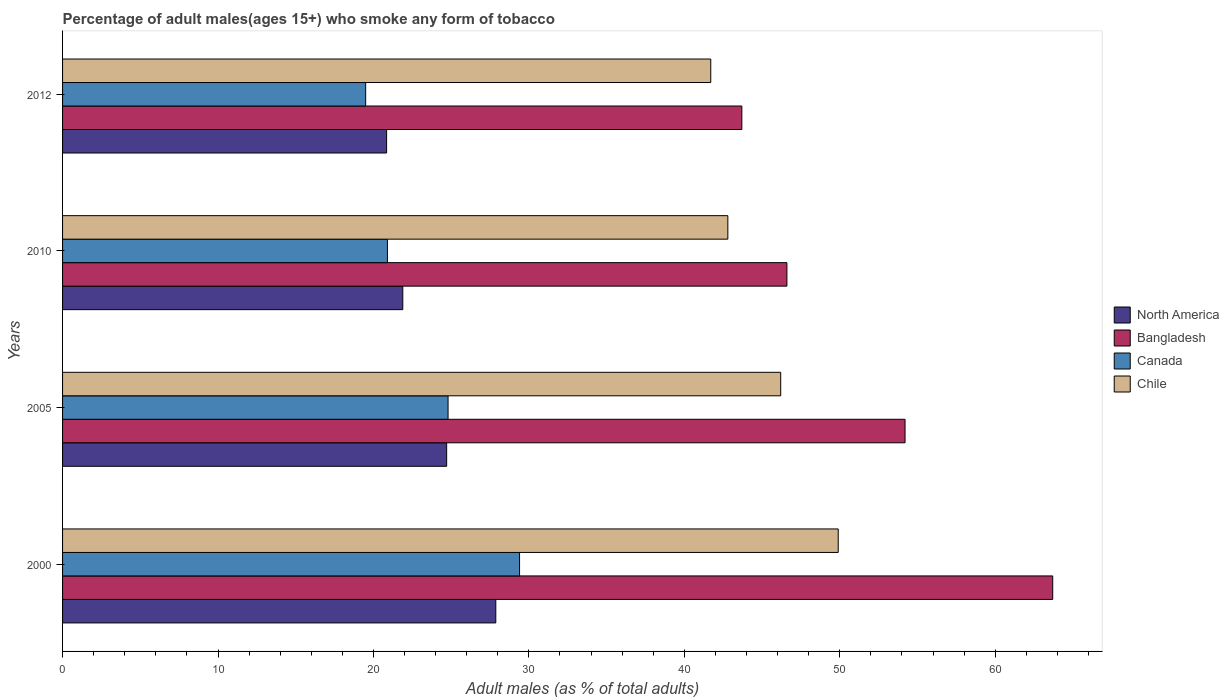How many bars are there on the 2nd tick from the top?
Your answer should be compact. 4. How many bars are there on the 2nd tick from the bottom?
Provide a short and direct response. 4. What is the label of the 4th group of bars from the top?
Offer a very short reply. 2000. In how many cases, is the number of bars for a given year not equal to the number of legend labels?
Provide a short and direct response. 0. What is the percentage of adult males who smoke in North America in 2005?
Your answer should be compact. 24.71. Across all years, what is the maximum percentage of adult males who smoke in Canada?
Keep it short and to the point. 29.4. Across all years, what is the minimum percentage of adult males who smoke in Canada?
Provide a succinct answer. 19.5. What is the total percentage of adult males who smoke in Canada in the graph?
Offer a terse response. 94.6. What is the difference between the percentage of adult males who smoke in Chile in 2000 and that in 2010?
Offer a very short reply. 7.1. What is the difference between the percentage of adult males who smoke in Bangladesh in 2010 and the percentage of adult males who smoke in Chile in 2000?
Provide a short and direct response. -3.3. What is the average percentage of adult males who smoke in Bangladesh per year?
Your response must be concise. 52.05. In the year 2005, what is the difference between the percentage of adult males who smoke in North America and percentage of adult males who smoke in Canada?
Give a very brief answer. -0.09. In how many years, is the percentage of adult males who smoke in North America greater than 26 %?
Give a very brief answer. 1. What is the ratio of the percentage of adult males who smoke in Canada in 2000 to that in 2005?
Keep it short and to the point. 1.19. Is the percentage of adult males who smoke in Bangladesh in 2000 less than that in 2012?
Provide a short and direct response. No. Is the difference between the percentage of adult males who smoke in North America in 2005 and 2012 greater than the difference between the percentage of adult males who smoke in Canada in 2005 and 2012?
Provide a short and direct response. No. What is the difference between the highest and the second highest percentage of adult males who smoke in Canada?
Your answer should be very brief. 4.6. What is the difference between the highest and the lowest percentage of adult males who smoke in North America?
Give a very brief answer. 7.02. In how many years, is the percentage of adult males who smoke in Chile greater than the average percentage of adult males who smoke in Chile taken over all years?
Your response must be concise. 2. Is the sum of the percentage of adult males who smoke in Canada in 2005 and 2012 greater than the maximum percentage of adult males who smoke in North America across all years?
Provide a succinct answer. Yes. Is it the case that in every year, the sum of the percentage of adult males who smoke in Chile and percentage of adult males who smoke in Bangladesh is greater than the sum of percentage of adult males who smoke in North America and percentage of adult males who smoke in Canada?
Provide a succinct answer. Yes. What does the 3rd bar from the top in 2000 represents?
Offer a terse response. Bangladesh. Is it the case that in every year, the sum of the percentage of adult males who smoke in North America and percentage of adult males who smoke in Chile is greater than the percentage of adult males who smoke in Bangladesh?
Make the answer very short. Yes. How many bars are there?
Give a very brief answer. 16. What is the difference between two consecutive major ticks on the X-axis?
Give a very brief answer. 10. Does the graph contain grids?
Make the answer very short. No. Where does the legend appear in the graph?
Offer a terse response. Center right. How are the legend labels stacked?
Offer a terse response. Vertical. What is the title of the graph?
Offer a terse response. Percentage of adult males(ages 15+) who smoke any form of tobacco. What is the label or title of the X-axis?
Provide a succinct answer. Adult males (as % of total adults). What is the label or title of the Y-axis?
Your response must be concise. Years. What is the Adult males (as % of total adults) of North America in 2000?
Your answer should be compact. 27.87. What is the Adult males (as % of total adults) in Bangladesh in 2000?
Offer a terse response. 63.7. What is the Adult males (as % of total adults) in Canada in 2000?
Make the answer very short. 29.4. What is the Adult males (as % of total adults) of Chile in 2000?
Offer a terse response. 49.9. What is the Adult males (as % of total adults) of North America in 2005?
Ensure brevity in your answer.  24.71. What is the Adult males (as % of total adults) in Bangladesh in 2005?
Your answer should be compact. 54.2. What is the Adult males (as % of total adults) in Canada in 2005?
Provide a short and direct response. 24.8. What is the Adult males (as % of total adults) of Chile in 2005?
Your answer should be very brief. 46.2. What is the Adult males (as % of total adults) of North America in 2010?
Make the answer very short. 21.89. What is the Adult males (as % of total adults) in Bangladesh in 2010?
Offer a terse response. 46.6. What is the Adult males (as % of total adults) in Canada in 2010?
Offer a terse response. 20.9. What is the Adult males (as % of total adults) of Chile in 2010?
Offer a very short reply. 42.8. What is the Adult males (as % of total adults) of North America in 2012?
Ensure brevity in your answer.  20.85. What is the Adult males (as % of total adults) in Bangladesh in 2012?
Offer a very short reply. 43.7. What is the Adult males (as % of total adults) of Canada in 2012?
Provide a short and direct response. 19.5. What is the Adult males (as % of total adults) in Chile in 2012?
Provide a short and direct response. 41.7. Across all years, what is the maximum Adult males (as % of total adults) in North America?
Offer a terse response. 27.87. Across all years, what is the maximum Adult males (as % of total adults) in Bangladesh?
Provide a short and direct response. 63.7. Across all years, what is the maximum Adult males (as % of total adults) in Canada?
Ensure brevity in your answer.  29.4. Across all years, what is the maximum Adult males (as % of total adults) of Chile?
Give a very brief answer. 49.9. Across all years, what is the minimum Adult males (as % of total adults) of North America?
Make the answer very short. 20.85. Across all years, what is the minimum Adult males (as % of total adults) in Bangladesh?
Offer a terse response. 43.7. Across all years, what is the minimum Adult males (as % of total adults) in Canada?
Your answer should be compact. 19.5. Across all years, what is the minimum Adult males (as % of total adults) of Chile?
Offer a terse response. 41.7. What is the total Adult males (as % of total adults) in North America in the graph?
Keep it short and to the point. 95.32. What is the total Adult males (as % of total adults) in Bangladesh in the graph?
Give a very brief answer. 208.2. What is the total Adult males (as % of total adults) in Canada in the graph?
Your response must be concise. 94.6. What is the total Adult males (as % of total adults) in Chile in the graph?
Make the answer very short. 180.6. What is the difference between the Adult males (as % of total adults) of North America in 2000 and that in 2005?
Offer a very short reply. 3.16. What is the difference between the Adult males (as % of total adults) of Chile in 2000 and that in 2005?
Offer a very short reply. 3.7. What is the difference between the Adult males (as % of total adults) of North America in 2000 and that in 2010?
Provide a short and direct response. 5.98. What is the difference between the Adult males (as % of total adults) in Chile in 2000 and that in 2010?
Your response must be concise. 7.1. What is the difference between the Adult males (as % of total adults) in North America in 2000 and that in 2012?
Your response must be concise. 7.02. What is the difference between the Adult males (as % of total adults) of Chile in 2000 and that in 2012?
Offer a terse response. 8.2. What is the difference between the Adult males (as % of total adults) of North America in 2005 and that in 2010?
Offer a very short reply. 2.82. What is the difference between the Adult males (as % of total adults) of North America in 2005 and that in 2012?
Your response must be concise. 3.86. What is the difference between the Adult males (as % of total adults) in Canada in 2005 and that in 2012?
Offer a terse response. 5.3. What is the difference between the Adult males (as % of total adults) in North America in 2010 and that in 2012?
Your answer should be very brief. 1.04. What is the difference between the Adult males (as % of total adults) in Chile in 2010 and that in 2012?
Your response must be concise. 1.1. What is the difference between the Adult males (as % of total adults) of North America in 2000 and the Adult males (as % of total adults) of Bangladesh in 2005?
Keep it short and to the point. -26.33. What is the difference between the Adult males (as % of total adults) in North America in 2000 and the Adult males (as % of total adults) in Canada in 2005?
Provide a succinct answer. 3.07. What is the difference between the Adult males (as % of total adults) in North America in 2000 and the Adult males (as % of total adults) in Chile in 2005?
Your answer should be compact. -18.33. What is the difference between the Adult males (as % of total adults) in Bangladesh in 2000 and the Adult males (as % of total adults) in Canada in 2005?
Your response must be concise. 38.9. What is the difference between the Adult males (as % of total adults) of Bangladesh in 2000 and the Adult males (as % of total adults) of Chile in 2005?
Offer a terse response. 17.5. What is the difference between the Adult males (as % of total adults) in Canada in 2000 and the Adult males (as % of total adults) in Chile in 2005?
Offer a very short reply. -16.8. What is the difference between the Adult males (as % of total adults) in North America in 2000 and the Adult males (as % of total adults) in Bangladesh in 2010?
Give a very brief answer. -18.73. What is the difference between the Adult males (as % of total adults) of North America in 2000 and the Adult males (as % of total adults) of Canada in 2010?
Make the answer very short. 6.97. What is the difference between the Adult males (as % of total adults) in North America in 2000 and the Adult males (as % of total adults) in Chile in 2010?
Give a very brief answer. -14.93. What is the difference between the Adult males (as % of total adults) in Bangladesh in 2000 and the Adult males (as % of total adults) in Canada in 2010?
Your answer should be very brief. 42.8. What is the difference between the Adult males (as % of total adults) of Bangladesh in 2000 and the Adult males (as % of total adults) of Chile in 2010?
Give a very brief answer. 20.9. What is the difference between the Adult males (as % of total adults) in North America in 2000 and the Adult males (as % of total adults) in Bangladesh in 2012?
Make the answer very short. -15.83. What is the difference between the Adult males (as % of total adults) of North America in 2000 and the Adult males (as % of total adults) of Canada in 2012?
Your answer should be compact. 8.37. What is the difference between the Adult males (as % of total adults) of North America in 2000 and the Adult males (as % of total adults) of Chile in 2012?
Your answer should be very brief. -13.83. What is the difference between the Adult males (as % of total adults) of Bangladesh in 2000 and the Adult males (as % of total adults) of Canada in 2012?
Keep it short and to the point. 44.2. What is the difference between the Adult males (as % of total adults) in Bangladesh in 2000 and the Adult males (as % of total adults) in Chile in 2012?
Your response must be concise. 22. What is the difference between the Adult males (as % of total adults) of Canada in 2000 and the Adult males (as % of total adults) of Chile in 2012?
Your answer should be very brief. -12.3. What is the difference between the Adult males (as % of total adults) of North America in 2005 and the Adult males (as % of total adults) of Bangladesh in 2010?
Offer a terse response. -21.89. What is the difference between the Adult males (as % of total adults) in North America in 2005 and the Adult males (as % of total adults) in Canada in 2010?
Give a very brief answer. 3.81. What is the difference between the Adult males (as % of total adults) of North America in 2005 and the Adult males (as % of total adults) of Chile in 2010?
Your answer should be compact. -18.09. What is the difference between the Adult males (as % of total adults) in Bangladesh in 2005 and the Adult males (as % of total adults) in Canada in 2010?
Give a very brief answer. 33.3. What is the difference between the Adult males (as % of total adults) in North America in 2005 and the Adult males (as % of total adults) in Bangladesh in 2012?
Give a very brief answer. -18.99. What is the difference between the Adult males (as % of total adults) in North America in 2005 and the Adult males (as % of total adults) in Canada in 2012?
Your response must be concise. 5.21. What is the difference between the Adult males (as % of total adults) in North America in 2005 and the Adult males (as % of total adults) in Chile in 2012?
Offer a terse response. -16.99. What is the difference between the Adult males (as % of total adults) of Bangladesh in 2005 and the Adult males (as % of total adults) of Canada in 2012?
Offer a terse response. 34.7. What is the difference between the Adult males (as % of total adults) in Bangladesh in 2005 and the Adult males (as % of total adults) in Chile in 2012?
Keep it short and to the point. 12.5. What is the difference between the Adult males (as % of total adults) in Canada in 2005 and the Adult males (as % of total adults) in Chile in 2012?
Your response must be concise. -16.9. What is the difference between the Adult males (as % of total adults) of North America in 2010 and the Adult males (as % of total adults) of Bangladesh in 2012?
Your response must be concise. -21.81. What is the difference between the Adult males (as % of total adults) in North America in 2010 and the Adult males (as % of total adults) in Canada in 2012?
Your answer should be compact. 2.39. What is the difference between the Adult males (as % of total adults) in North America in 2010 and the Adult males (as % of total adults) in Chile in 2012?
Give a very brief answer. -19.81. What is the difference between the Adult males (as % of total adults) of Bangladesh in 2010 and the Adult males (as % of total adults) of Canada in 2012?
Offer a very short reply. 27.1. What is the difference between the Adult males (as % of total adults) of Bangladesh in 2010 and the Adult males (as % of total adults) of Chile in 2012?
Ensure brevity in your answer.  4.9. What is the difference between the Adult males (as % of total adults) in Canada in 2010 and the Adult males (as % of total adults) in Chile in 2012?
Provide a short and direct response. -20.8. What is the average Adult males (as % of total adults) in North America per year?
Make the answer very short. 23.83. What is the average Adult males (as % of total adults) in Bangladesh per year?
Ensure brevity in your answer.  52.05. What is the average Adult males (as % of total adults) in Canada per year?
Offer a very short reply. 23.65. What is the average Adult males (as % of total adults) in Chile per year?
Your response must be concise. 45.15. In the year 2000, what is the difference between the Adult males (as % of total adults) of North America and Adult males (as % of total adults) of Bangladesh?
Your answer should be very brief. -35.83. In the year 2000, what is the difference between the Adult males (as % of total adults) in North America and Adult males (as % of total adults) in Canada?
Your response must be concise. -1.53. In the year 2000, what is the difference between the Adult males (as % of total adults) of North America and Adult males (as % of total adults) of Chile?
Provide a succinct answer. -22.03. In the year 2000, what is the difference between the Adult males (as % of total adults) in Bangladesh and Adult males (as % of total adults) in Canada?
Provide a succinct answer. 34.3. In the year 2000, what is the difference between the Adult males (as % of total adults) in Canada and Adult males (as % of total adults) in Chile?
Keep it short and to the point. -20.5. In the year 2005, what is the difference between the Adult males (as % of total adults) of North America and Adult males (as % of total adults) of Bangladesh?
Keep it short and to the point. -29.49. In the year 2005, what is the difference between the Adult males (as % of total adults) in North America and Adult males (as % of total adults) in Canada?
Your response must be concise. -0.09. In the year 2005, what is the difference between the Adult males (as % of total adults) of North America and Adult males (as % of total adults) of Chile?
Provide a succinct answer. -21.49. In the year 2005, what is the difference between the Adult males (as % of total adults) in Bangladesh and Adult males (as % of total adults) in Canada?
Your response must be concise. 29.4. In the year 2005, what is the difference between the Adult males (as % of total adults) of Bangladesh and Adult males (as % of total adults) of Chile?
Give a very brief answer. 8. In the year 2005, what is the difference between the Adult males (as % of total adults) in Canada and Adult males (as % of total adults) in Chile?
Keep it short and to the point. -21.4. In the year 2010, what is the difference between the Adult males (as % of total adults) in North America and Adult males (as % of total adults) in Bangladesh?
Your response must be concise. -24.71. In the year 2010, what is the difference between the Adult males (as % of total adults) in North America and Adult males (as % of total adults) in Chile?
Provide a succinct answer. -20.91. In the year 2010, what is the difference between the Adult males (as % of total adults) in Bangladesh and Adult males (as % of total adults) in Canada?
Keep it short and to the point. 25.7. In the year 2010, what is the difference between the Adult males (as % of total adults) of Canada and Adult males (as % of total adults) of Chile?
Your answer should be compact. -21.9. In the year 2012, what is the difference between the Adult males (as % of total adults) of North America and Adult males (as % of total adults) of Bangladesh?
Ensure brevity in your answer.  -22.85. In the year 2012, what is the difference between the Adult males (as % of total adults) in North America and Adult males (as % of total adults) in Canada?
Your answer should be very brief. 1.35. In the year 2012, what is the difference between the Adult males (as % of total adults) of North America and Adult males (as % of total adults) of Chile?
Make the answer very short. -20.85. In the year 2012, what is the difference between the Adult males (as % of total adults) in Bangladesh and Adult males (as % of total adults) in Canada?
Offer a terse response. 24.2. In the year 2012, what is the difference between the Adult males (as % of total adults) in Bangladesh and Adult males (as % of total adults) in Chile?
Ensure brevity in your answer.  2. In the year 2012, what is the difference between the Adult males (as % of total adults) of Canada and Adult males (as % of total adults) of Chile?
Your answer should be compact. -22.2. What is the ratio of the Adult males (as % of total adults) of North America in 2000 to that in 2005?
Keep it short and to the point. 1.13. What is the ratio of the Adult males (as % of total adults) of Bangladesh in 2000 to that in 2005?
Keep it short and to the point. 1.18. What is the ratio of the Adult males (as % of total adults) of Canada in 2000 to that in 2005?
Your answer should be compact. 1.19. What is the ratio of the Adult males (as % of total adults) of Chile in 2000 to that in 2005?
Provide a short and direct response. 1.08. What is the ratio of the Adult males (as % of total adults) of North America in 2000 to that in 2010?
Offer a terse response. 1.27. What is the ratio of the Adult males (as % of total adults) of Bangladesh in 2000 to that in 2010?
Ensure brevity in your answer.  1.37. What is the ratio of the Adult males (as % of total adults) in Canada in 2000 to that in 2010?
Your answer should be compact. 1.41. What is the ratio of the Adult males (as % of total adults) in Chile in 2000 to that in 2010?
Ensure brevity in your answer.  1.17. What is the ratio of the Adult males (as % of total adults) in North America in 2000 to that in 2012?
Offer a terse response. 1.34. What is the ratio of the Adult males (as % of total adults) of Bangladesh in 2000 to that in 2012?
Offer a terse response. 1.46. What is the ratio of the Adult males (as % of total adults) in Canada in 2000 to that in 2012?
Offer a very short reply. 1.51. What is the ratio of the Adult males (as % of total adults) in Chile in 2000 to that in 2012?
Offer a terse response. 1.2. What is the ratio of the Adult males (as % of total adults) of North America in 2005 to that in 2010?
Keep it short and to the point. 1.13. What is the ratio of the Adult males (as % of total adults) of Bangladesh in 2005 to that in 2010?
Your answer should be very brief. 1.16. What is the ratio of the Adult males (as % of total adults) in Canada in 2005 to that in 2010?
Offer a very short reply. 1.19. What is the ratio of the Adult males (as % of total adults) in Chile in 2005 to that in 2010?
Keep it short and to the point. 1.08. What is the ratio of the Adult males (as % of total adults) in North America in 2005 to that in 2012?
Your answer should be compact. 1.19. What is the ratio of the Adult males (as % of total adults) of Bangladesh in 2005 to that in 2012?
Your answer should be very brief. 1.24. What is the ratio of the Adult males (as % of total adults) of Canada in 2005 to that in 2012?
Your answer should be compact. 1.27. What is the ratio of the Adult males (as % of total adults) of Chile in 2005 to that in 2012?
Offer a terse response. 1.11. What is the ratio of the Adult males (as % of total adults) of North America in 2010 to that in 2012?
Provide a succinct answer. 1.05. What is the ratio of the Adult males (as % of total adults) in Bangladesh in 2010 to that in 2012?
Make the answer very short. 1.07. What is the ratio of the Adult males (as % of total adults) in Canada in 2010 to that in 2012?
Provide a short and direct response. 1.07. What is the ratio of the Adult males (as % of total adults) of Chile in 2010 to that in 2012?
Provide a succinct answer. 1.03. What is the difference between the highest and the second highest Adult males (as % of total adults) in North America?
Provide a succinct answer. 3.16. What is the difference between the highest and the second highest Adult males (as % of total adults) of Canada?
Your answer should be very brief. 4.6. What is the difference between the highest and the second highest Adult males (as % of total adults) in Chile?
Ensure brevity in your answer.  3.7. What is the difference between the highest and the lowest Adult males (as % of total adults) of North America?
Ensure brevity in your answer.  7.02. What is the difference between the highest and the lowest Adult males (as % of total adults) of Bangladesh?
Your response must be concise. 20. What is the difference between the highest and the lowest Adult males (as % of total adults) in Canada?
Offer a very short reply. 9.9. 